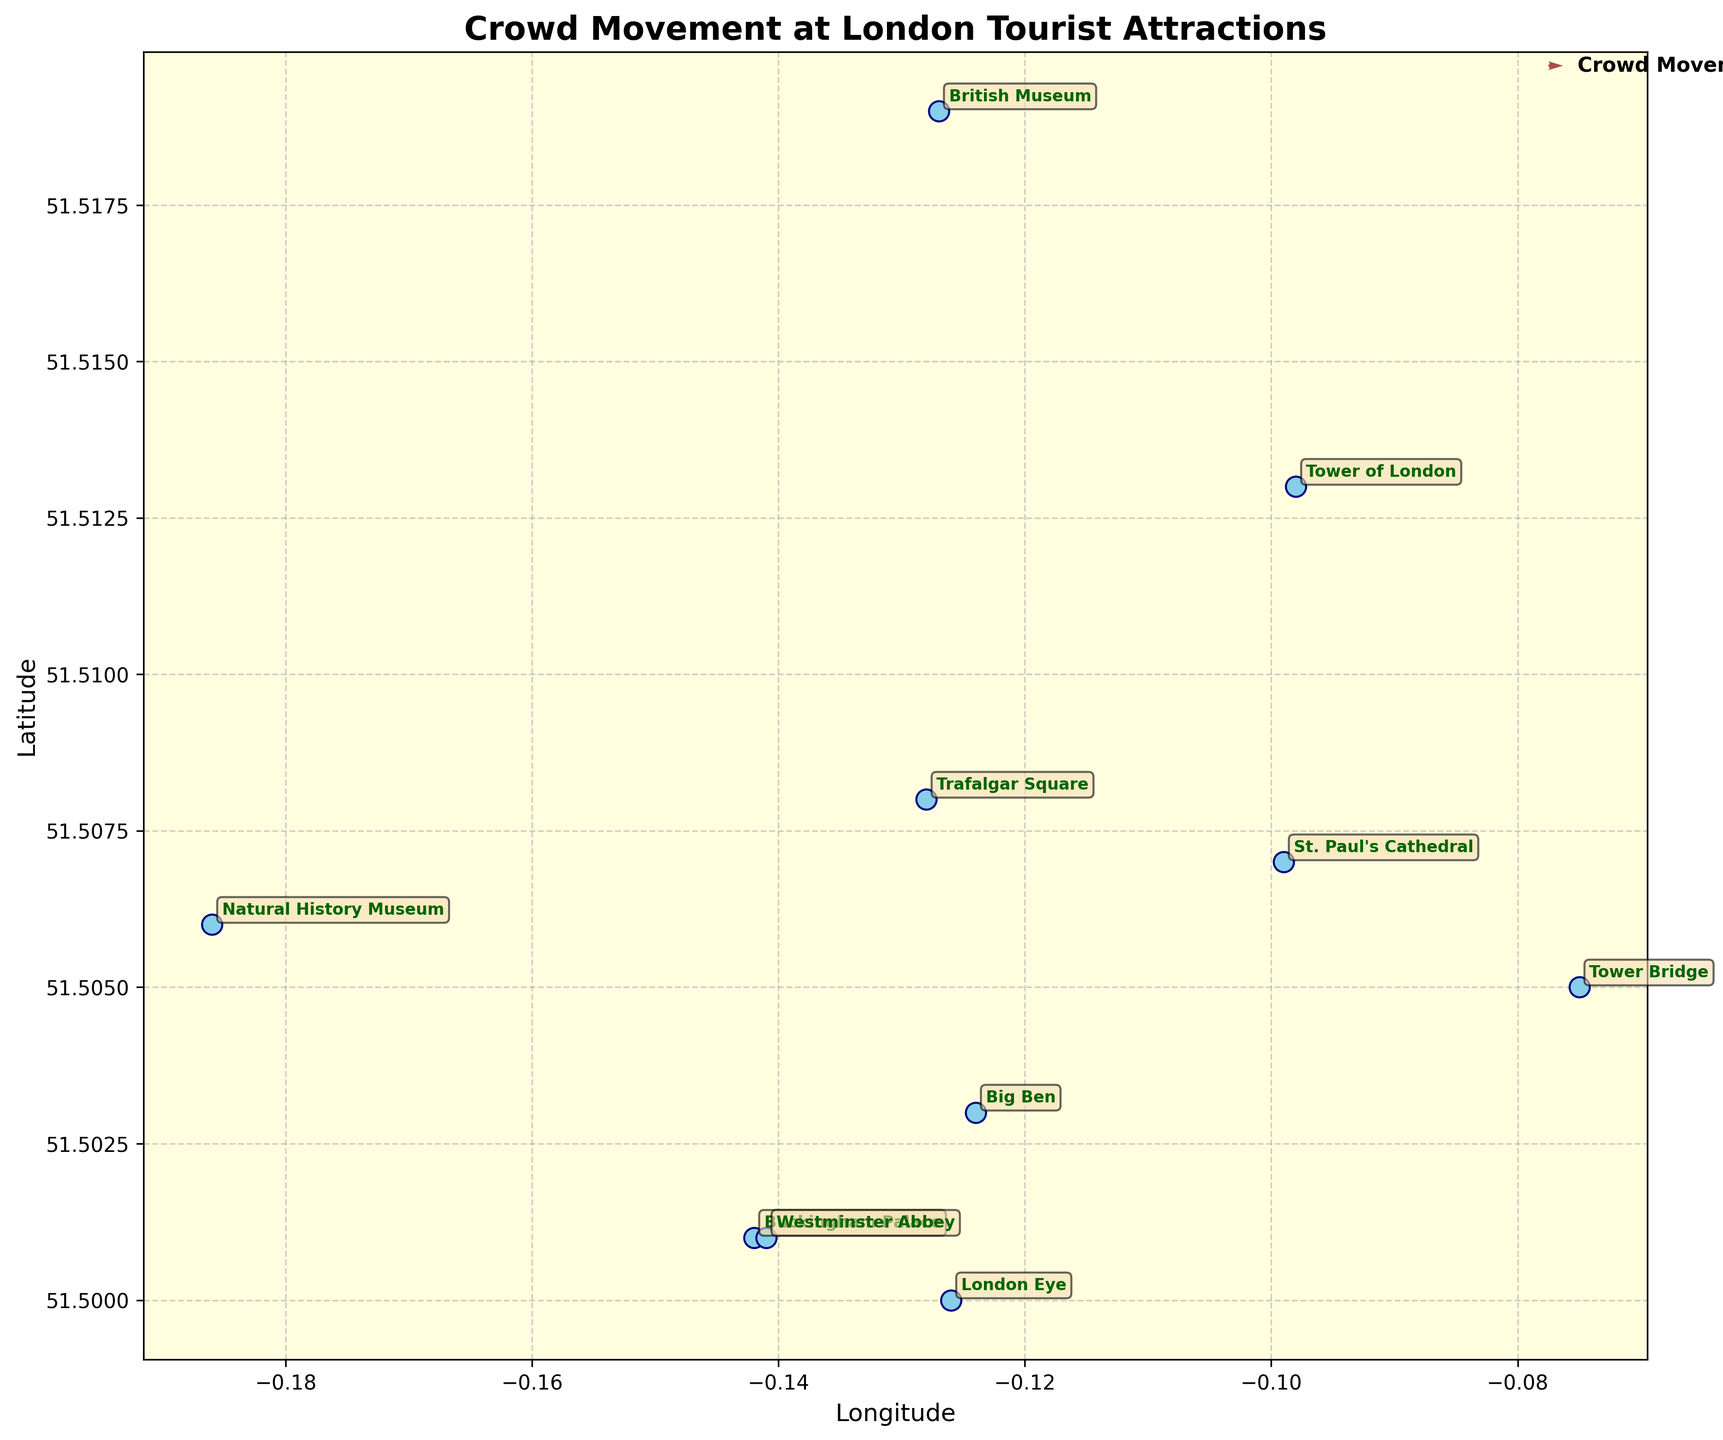What's the title of the figure? The title of the figure is displayed at the top of the plot. It is designed to give a quick overview of what the plot is depicting.
Answer: Crowd Movement at London Tourist Attractions How many tourist attractions are shown in the plot? The plot displays each tourist attraction with its name annotated next to it. By counting these annotations, we can determine the number of attractions.
Answer: 10 What general direction are the crowds moving around Buckingham Palace? The quiver arrow at Buckingham Palace points from the origin of the arrow. The arrow represents the direction of crowd movement, which is slightly southwest.
Answer: Southwest Which attraction has the northward crowd movement with the highest magnitude? Look for the longest arrow pointing northward. This is identified by examining the upward component ('u') of the vectors originating from the attractions.
Answer: London Eye Compare the crowd movements at Trafalgar Square and Tower of London. Which direction are they moving towards? Examine the direction vectors ('v' and 'u') associated with Trafalgar Square and Tower of London. Analyze the arrow directions from these points to determine the crowd movement.
Answer: Trafalgar Square: Northeast, Tower of London: Northeast Which attraction shows the smallest crowd movement? The length of the vector represents the crowd movement magnitude. Identify the shortest arrow on the plot to find the attraction with the smallest movement.
Answer: British Museum Is the movement towards Big Ben more to the east or to the north? Analyze the direction of the arrow from Big Ben. Evaluate the components of movement (east-west 'v' and north-south 'u'). A longer 'v' component suggests more eastward movement.
Answer: North What general direction is the crowd moving at Tower Bridge? Determine the direction of the arrow originating from Tower Bridge. The arrow points towards the general direction of movement.
Answer: Northeast 